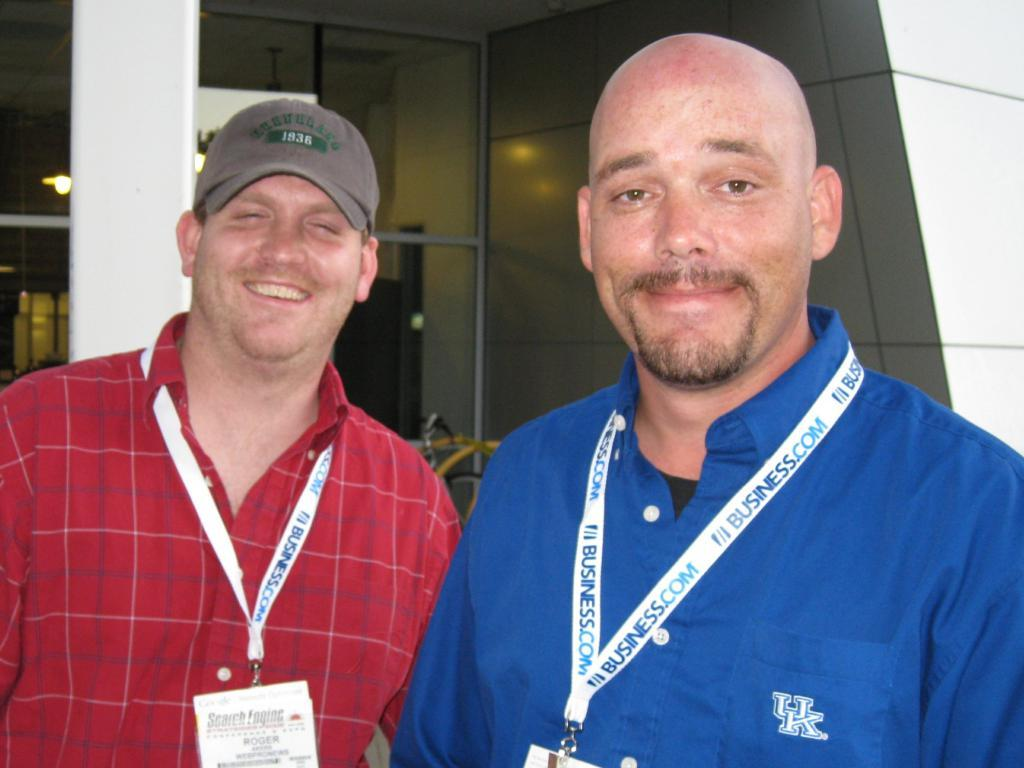<image>
Present a compact description of the photo's key features. The man on the right wears a blue shirt from UK. 